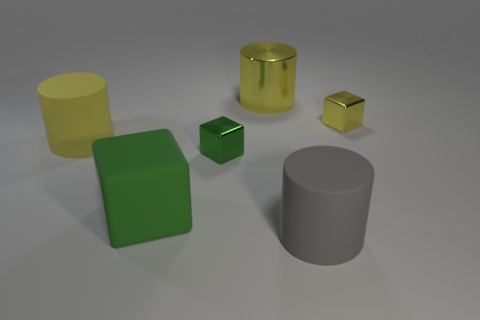Subtract all large yellow matte cylinders. How many cylinders are left? 2 Subtract all red balls. How many green cubes are left? 2 Subtract all gray cylinders. How many cylinders are left? 2 Subtract 1 cylinders. How many cylinders are left? 2 Subtract all brown cylinders. Subtract all brown balls. How many cylinders are left? 3 Add 2 small brown rubber cubes. How many objects exist? 8 Subtract 1 gray cylinders. How many objects are left? 5 Subtract all tiny yellow things. Subtract all tiny things. How many objects are left? 3 Add 6 big gray cylinders. How many big gray cylinders are left? 7 Add 5 big matte objects. How many big matte objects exist? 8 